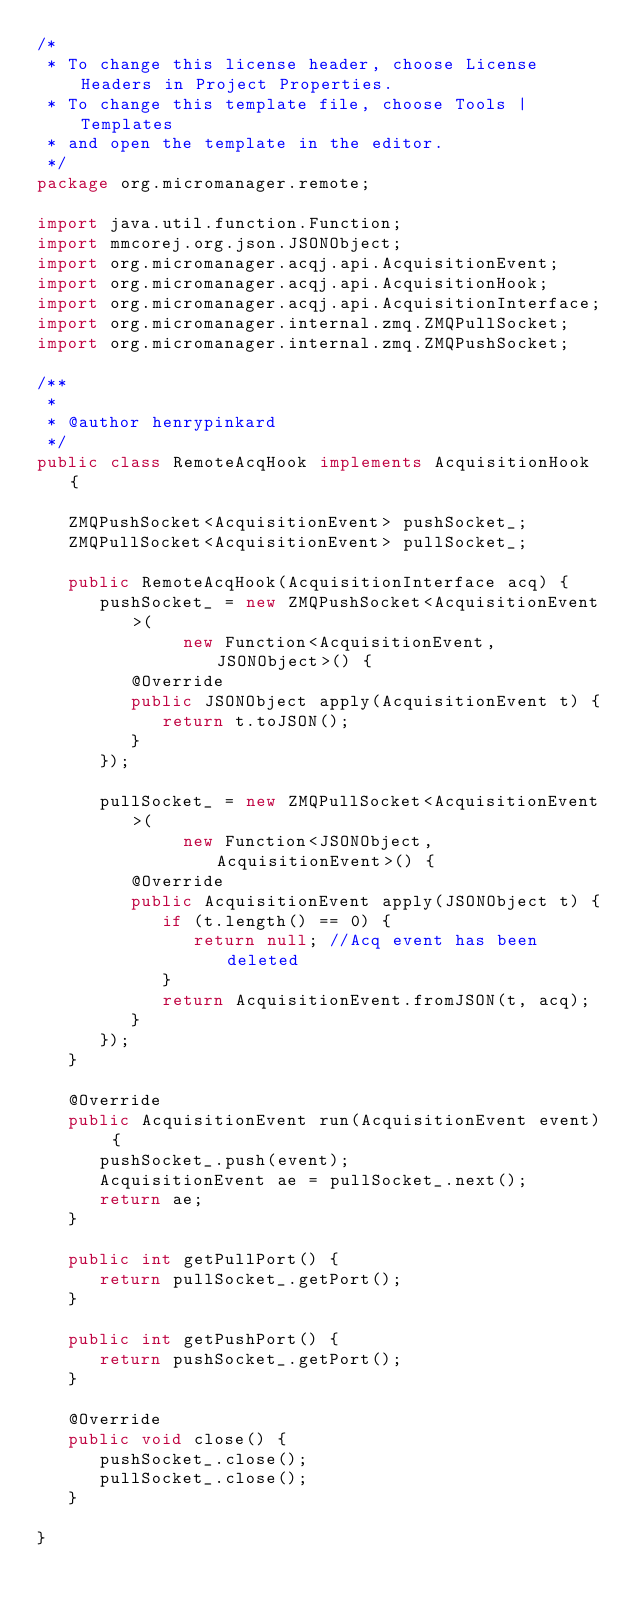<code> <loc_0><loc_0><loc_500><loc_500><_Java_>/*
 * To change this license header, choose License Headers in Project Properties.
 * To change this template file, choose Tools | Templates
 * and open the template in the editor.
 */
package org.micromanager.remote;

import java.util.function.Function;
import mmcorej.org.json.JSONObject;
import org.micromanager.acqj.api.AcquisitionEvent;
import org.micromanager.acqj.api.AcquisitionHook;
import org.micromanager.acqj.api.AcquisitionInterface;
import org.micromanager.internal.zmq.ZMQPullSocket;
import org.micromanager.internal.zmq.ZMQPushSocket;

/**
 *
 * @author henrypinkard
 */
public class RemoteAcqHook implements AcquisitionHook {

   ZMQPushSocket<AcquisitionEvent> pushSocket_;
   ZMQPullSocket<AcquisitionEvent> pullSocket_;

   public RemoteAcqHook(AcquisitionInterface acq) {
      pushSocket_ = new ZMQPushSocket<AcquisitionEvent>(
              new Function<AcquisitionEvent, JSONObject>() {
         @Override
         public JSONObject apply(AcquisitionEvent t) {
            return t.toJSON();
         }
      });

      pullSocket_ = new ZMQPullSocket<AcquisitionEvent>(
              new Function<JSONObject, AcquisitionEvent>() {
         @Override
         public AcquisitionEvent apply(JSONObject t) {
            if (t.length() == 0) {
               return null; //Acq event has been deleted
            }
            return AcquisitionEvent.fromJSON(t, acq);
         }
      });
   }

   @Override
   public AcquisitionEvent run(AcquisitionEvent event) {
      pushSocket_.push(event);
      AcquisitionEvent ae = pullSocket_.next();
      return ae;
   }

   public int getPullPort() {
      return pullSocket_.getPort();
   }

   public int getPushPort() {
      return pushSocket_.getPort();
   }

   @Override
   public void close() {
      pushSocket_.close();
      pullSocket_.close();
   }

}
</code> 